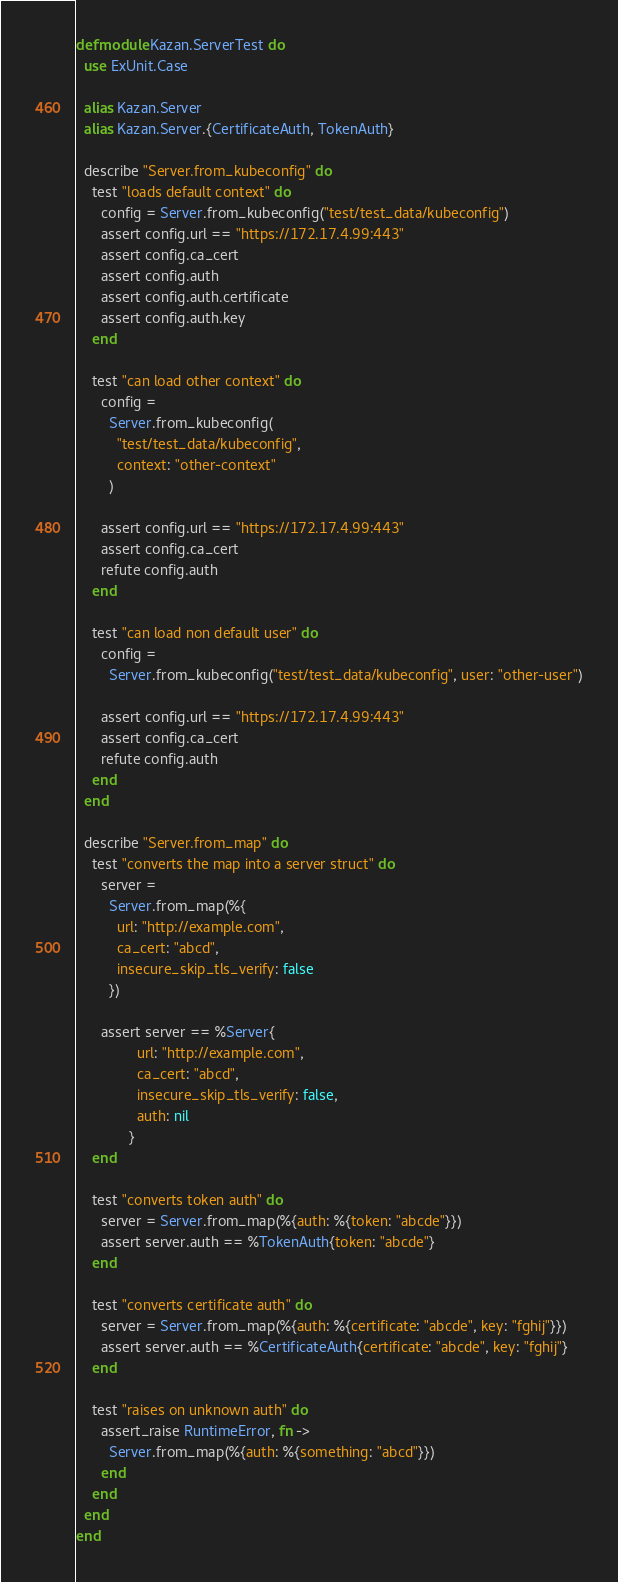<code> <loc_0><loc_0><loc_500><loc_500><_Elixir_>defmodule Kazan.ServerTest do
  use ExUnit.Case

  alias Kazan.Server
  alias Kazan.Server.{CertificateAuth, TokenAuth}

  describe "Server.from_kubeconfig" do
    test "loads default context" do
      config = Server.from_kubeconfig("test/test_data/kubeconfig")
      assert config.url == "https://172.17.4.99:443"
      assert config.ca_cert
      assert config.auth
      assert config.auth.certificate
      assert config.auth.key
    end

    test "can load other context" do
      config =
        Server.from_kubeconfig(
          "test/test_data/kubeconfig",
          context: "other-context"
        )

      assert config.url == "https://172.17.4.99:443"
      assert config.ca_cert
      refute config.auth
    end

    test "can load non default user" do
      config =
        Server.from_kubeconfig("test/test_data/kubeconfig", user: "other-user")

      assert config.url == "https://172.17.4.99:443"
      assert config.ca_cert
      refute config.auth
    end
  end

  describe "Server.from_map" do
    test "converts the map into a server struct" do
      server =
        Server.from_map(%{
          url: "http://example.com",
          ca_cert: "abcd",
          insecure_skip_tls_verify: false
        })

      assert server == %Server{
               url: "http://example.com",
               ca_cert: "abcd",
               insecure_skip_tls_verify: false,
               auth: nil
             }
    end

    test "converts token auth" do
      server = Server.from_map(%{auth: %{token: "abcde"}})
      assert server.auth == %TokenAuth{token: "abcde"}
    end

    test "converts certificate auth" do
      server = Server.from_map(%{auth: %{certificate: "abcde", key: "fghij"}})
      assert server.auth == %CertificateAuth{certificate: "abcde", key: "fghij"}
    end

    test "raises on unknown auth" do
      assert_raise RuntimeError, fn ->
        Server.from_map(%{auth: %{something: "abcd"}})
      end
    end
  end
end
</code> 